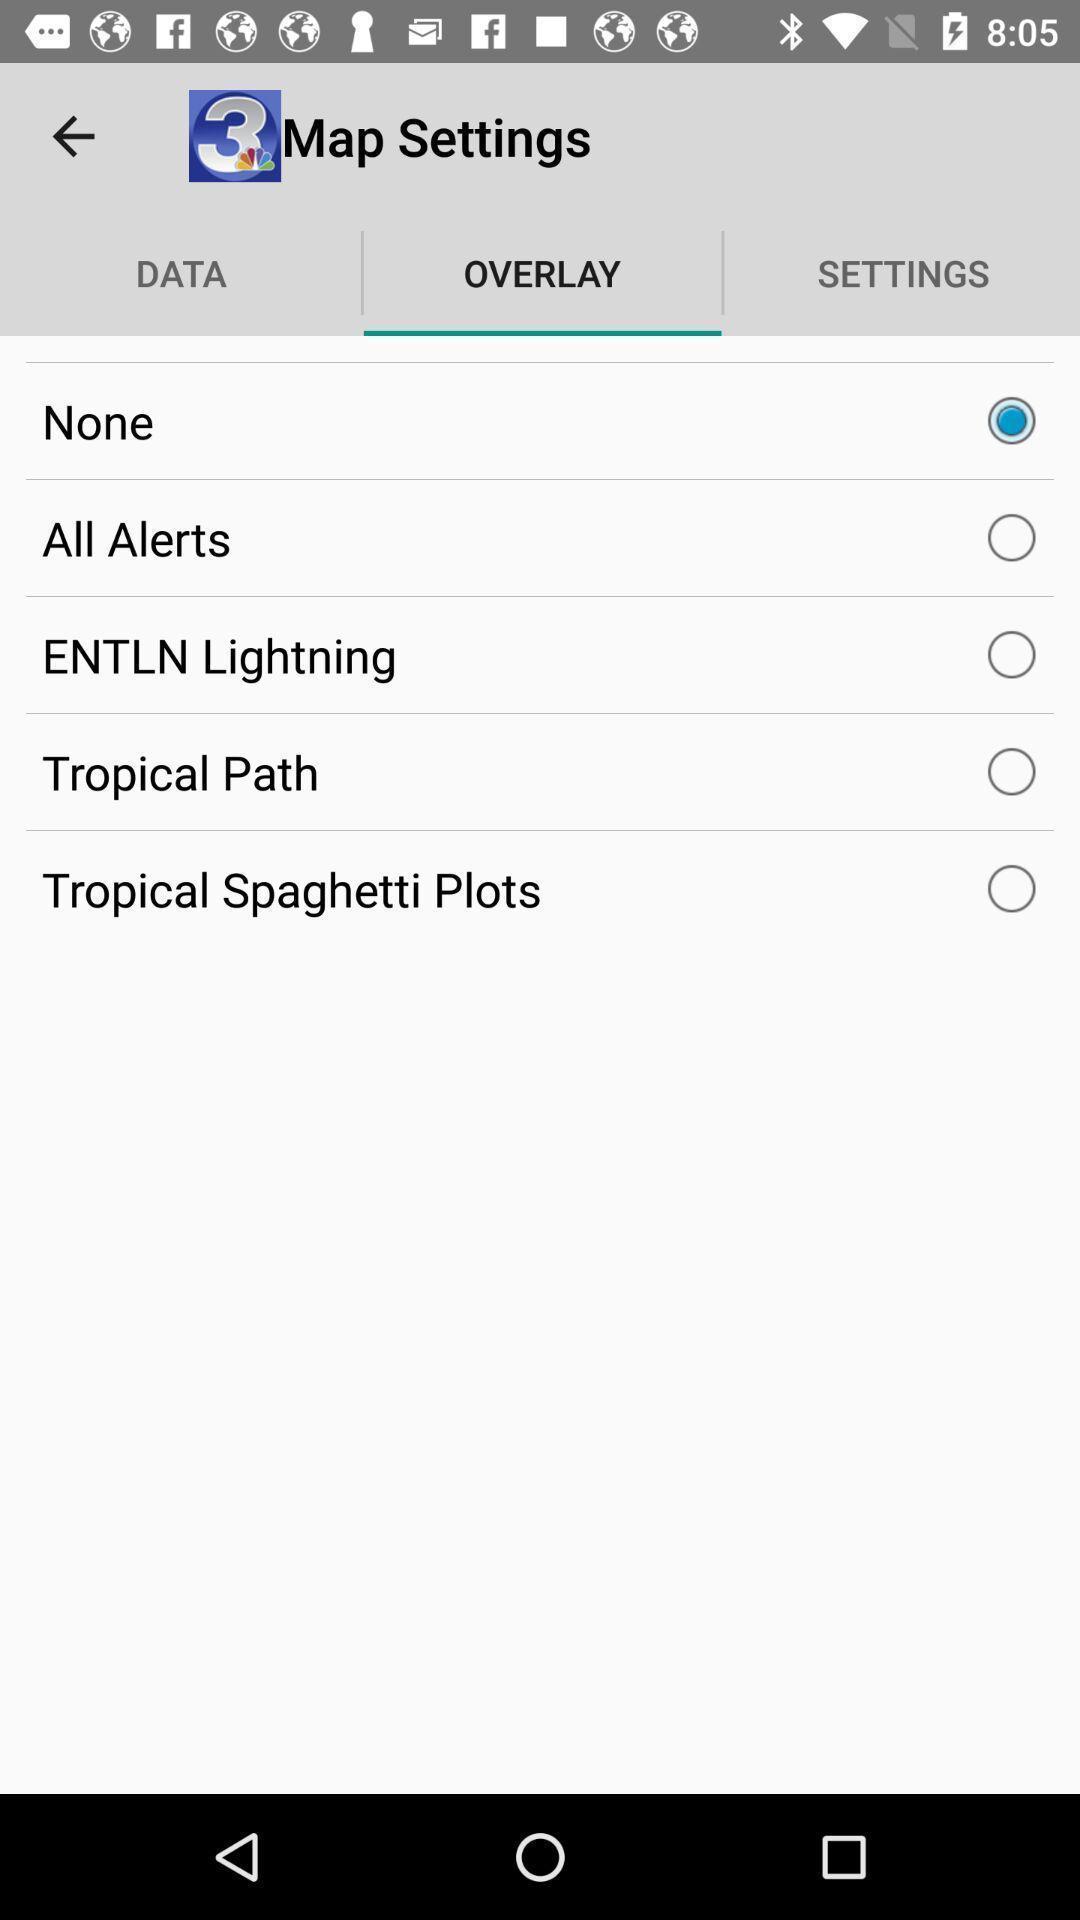Describe this image in words. Page showing the settings. 